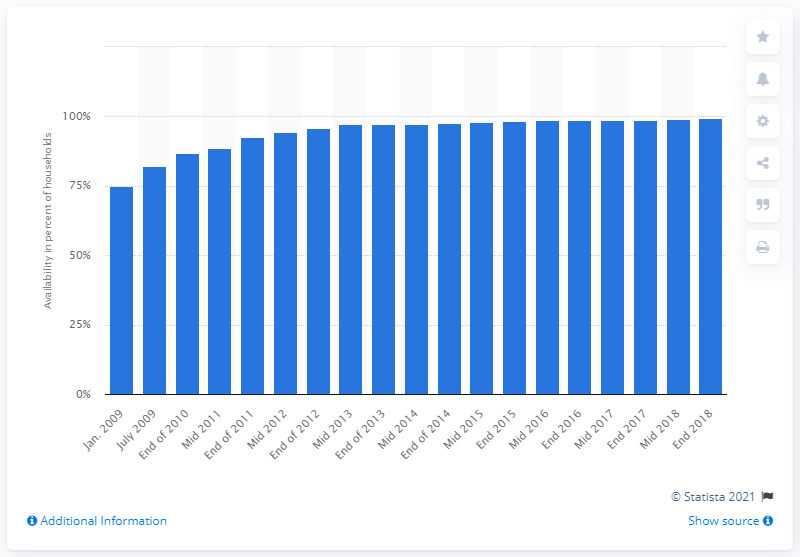Identify some key points in this picture. As of the end of 2018, in areas with a population density below 100 inhabitants per square kilometer, approximately 99.5% of households had access to broadband internet. 